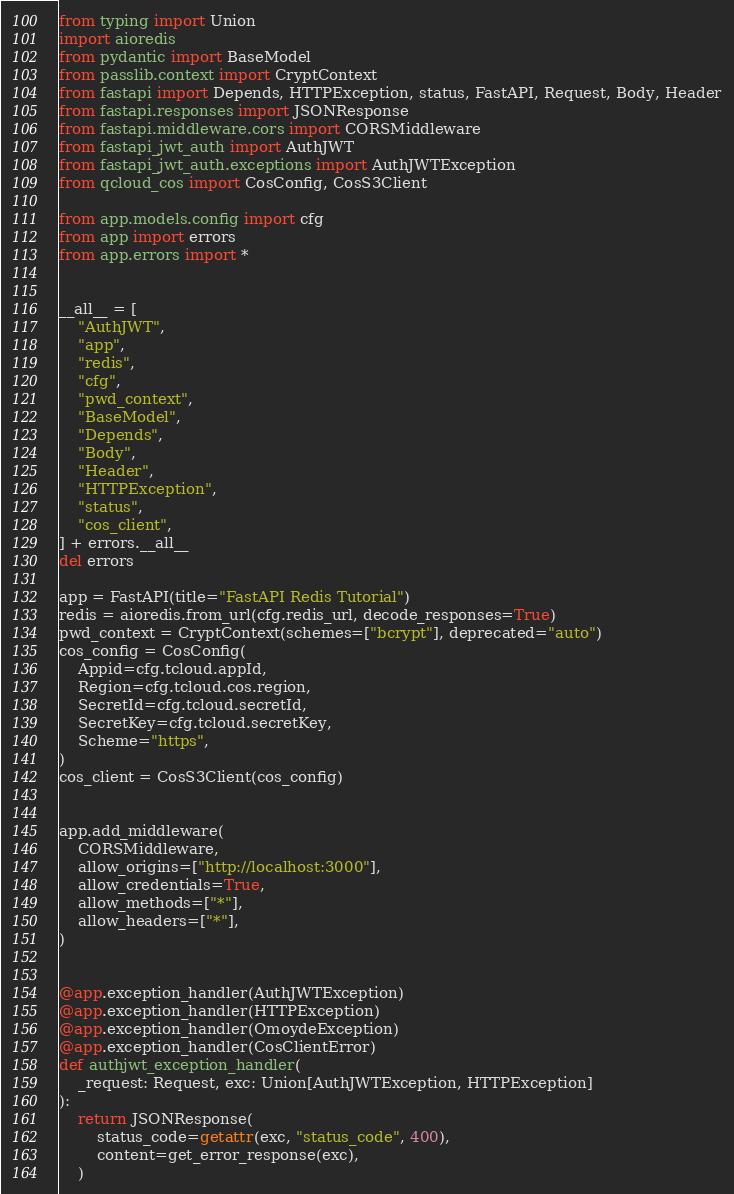Convert code to text. <code><loc_0><loc_0><loc_500><loc_500><_Python_>from typing import Union
import aioredis
from pydantic import BaseModel
from passlib.context import CryptContext
from fastapi import Depends, HTTPException, status, FastAPI, Request, Body, Header
from fastapi.responses import JSONResponse
from fastapi.middleware.cors import CORSMiddleware
from fastapi_jwt_auth import AuthJWT
from fastapi_jwt_auth.exceptions import AuthJWTException
from qcloud_cos import CosConfig, CosS3Client

from app.models.config import cfg
from app import errors
from app.errors import *


__all__ = [
    "AuthJWT",
    "app",
    "redis",
    "cfg",
    "pwd_context",
    "BaseModel",
    "Depends",
    "Body",
    "Header",
    "HTTPException",
    "status",
    "cos_client",
] + errors.__all__
del errors

app = FastAPI(title="FastAPI Redis Tutorial")
redis = aioredis.from_url(cfg.redis_url, decode_responses=True)
pwd_context = CryptContext(schemes=["bcrypt"], deprecated="auto")
cos_config = CosConfig(
    Appid=cfg.tcloud.appId,
    Region=cfg.tcloud.cos.region,
    SecretId=cfg.tcloud.secretId,
    SecretKey=cfg.tcloud.secretKey,
    Scheme="https",
)
cos_client = CosS3Client(cos_config)


app.add_middleware(
    CORSMiddleware,
    allow_origins=["http://localhost:3000"],
    allow_credentials=True,
    allow_methods=["*"],
    allow_headers=["*"],
)


@app.exception_handler(AuthJWTException)
@app.exception_handler(HTTPException)
@app.exception_handler(OmoydeException)
@app.exception_handler(CosClientError)
def authjwt_exception_handler(
    _request: Request, exc: Union[AuthJWTException, HTTPException]
):
    return JSONResponse(
        status_code=getattr(exc, "status_code", 400),
        content=get_error_response(exc),
    )
</code> 